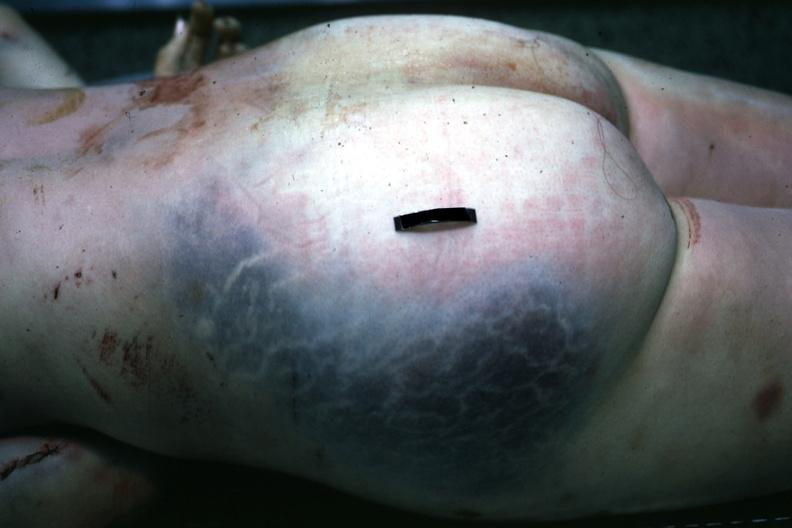how is large gluteal hematoma seen at through the skin?
Answer the question using a single word or phrase. Autopsy 